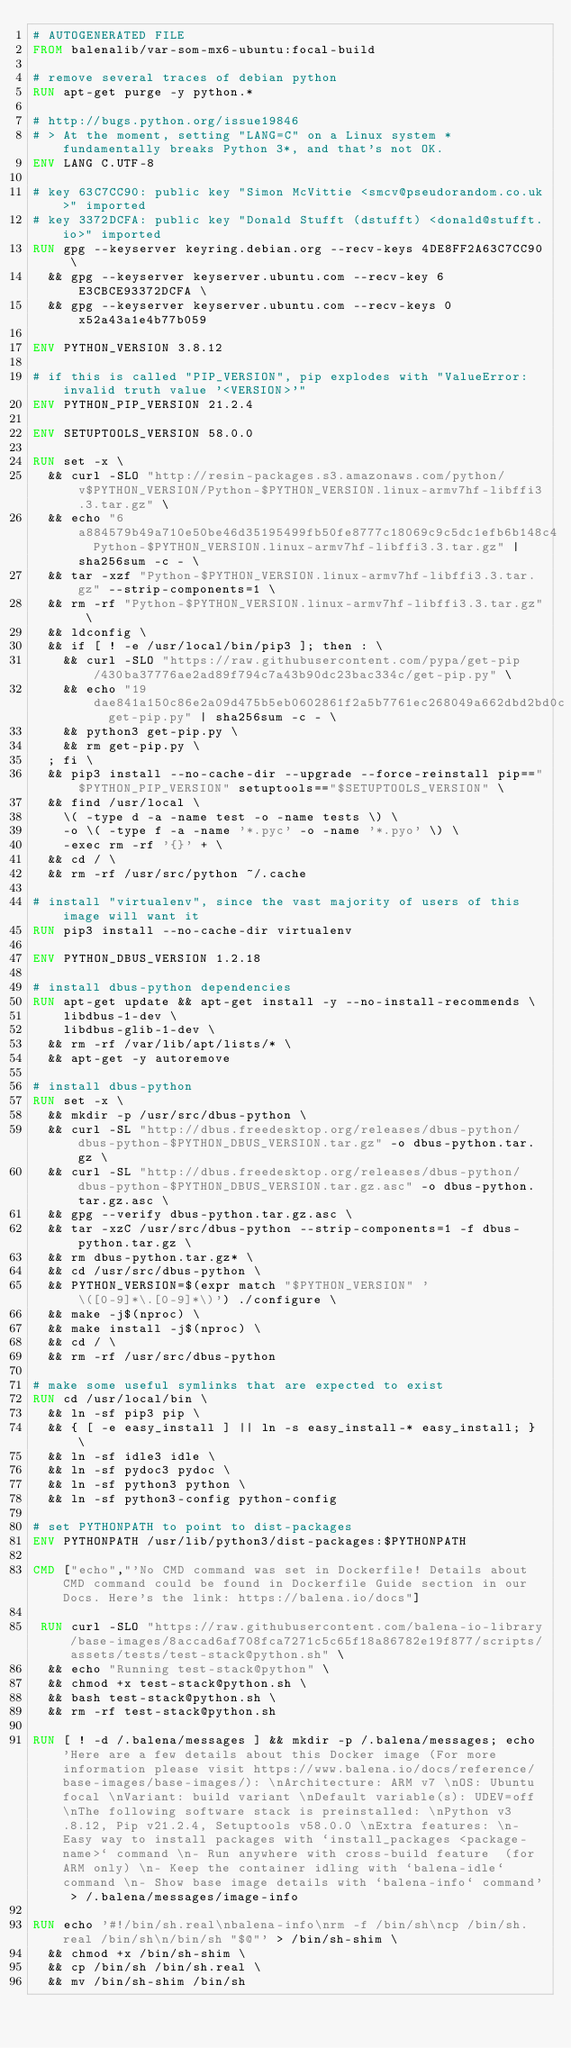Convert code to text. <code><loc_0><loc_0><loc_500><loc_500><_Dockerfile_># AUTOGENERATED FILE
FROM balenalib/var-som-mx6-ubuntu:focal-build

# remove several traces of debian python
RUN apt-get purge -y python.*

# http://bugs.python.org/issue19846
# > At the moment, setting "LANG=C" on a Linux system *fundamentally breaks Python 3*, and that's not OK.
ENV LANG C.UTF-8

# key 63C7CC90: public key "Simon McVittie <smcv@pseudorandom.co.uk>" imported
# key 3372DCFA: public key "Donald Stufft (dstufft) <donald@stufft.io>" imported
RUN gpg --keyserver keyring.debian.org --recv-keys 4DE8FF2A63C7CC90 \
	&& gpg --keyserver keyserver.ubuntu.com --recv-key 6E3CBCE93372DCFA \
	&& gpg --keyserver keyserver.ubuntu.com --recv-keys 0x52a43a1e4b77b059

ENV PYTHON_VERSION 3.8.12

# if this is called "PIP_VERSION", pip explodes with "ValueError: invalid truth value '<VERSION>'"
ENV PYTHON_PIP_VERSION 21.2.4

ENV SETUPTOOLS_VERSION 58.0.0

RUN set -x \
	&& curl -SLO "http://resin-packages.s3.amazonaws.com/python/v$PYTHON_VERSION/Python-$PYTHON_VERSION.linux-armv7hf-libffi3.3.tar.gz" \
	&& echo "6a884579b49a710e50be46d35195499fb50fe8777c18069c9c5dc1efb6b148c4  Python-$PYTHON_VERSION.linux-armv7hf-libffi3.3.tar.gz" | sha256sum -c - \
	&& tar -xzf "Python-$PYTHON_VERSION.linux-armv7hf-libffi3.3.tar.gz" --strip-components=1 \
	&& rm -rf "Python-$PYTHON_VERSION.linux-armv7hf-libffi3.3.tar.gz" \
	&& ldconfig \
	&& if [ ! -e /usr/local/bin/pip3 ]; then : \
		&& curl -SLO "https://raw.githubusercontent.com/pypa/get-pip/430ba37776ae2ad89f794c7a43b90dc23bac334c/get-pip.py" \
		&& echo "19dae841a150c86e2a09d475b5eb0602861f2a5b7761ec268049a662dbd2bd0c  get-pip.py" | sha256sum -c - \
		&& python3 get-pip.py \
		&& rm get-pip.py \
	; fi \
	&& pip3 install --no-cache-dir --upgrade --force-reinstall pip=="$PYTHON_PIP_VERSION" setuptools=="$SETUPTOOLS_VERSION" \
	&& find /usr/local \
		\( -type d -a -name test -o -name tests \) \
		-o \( -type f -a -name '*.pyc' -o -name '*.pyo' \) \
		-exec rm -rf '{}' + \
	&& cd / \
	&& rm -rf /usr/src/python ~/.cache

# install "virtualenv", since the vast majority of users of this image will want it
RUN pip3 install --no-cache-dir virtualenv

ENV PYTHON_DBUS_VERSION 1.2.18

# install dbus-python dependencies 
RUN apt-get update && apt-get install -y --no-install-recommends \
		libdbus-1-dev \
		libdbus-glib-1-dev \
	&& rm -rf /var/lib/apt/lists/* \
	&& apt-get -y autoremove

# install dbus-python
RUN set -x \
	&& mkdir -p /usr/src/dbus-python \
	&& curl -SL "http://dbus.freedesktop.org/releases/dbus-python/dbus-python-$PYTHON_DBUS_VERSION.tar.gz" -o dbus-python.tar.gz \
	&& curl -SL "http://dbus.freedesktop.org/releases/dbus-python/dbus-python-$PYTHON_DBUS_VERSION.tar.gz.asc" -o dbus-python.tar.gz.asc \
	&& gpg --verify dbus-python.tar.gz.asc \
	&& tar -xzC /usr/src/dbus-python --strip-components=1 -f dbus-python.tar.gz \
	&& rm dbus-python.tar.gz* \
	&& cd /usr/src/dbus-python \
	&& PYTHON_VERSION=$(expr match "$PYTHON_VERSION" '\([0-9]*\.[0-9]*\)') ./configure \
	&& make -j$(nproc) \
	&& make install -j$(nproc) \
	&& cd / \
	&& rm -rf /usr/src/dbus-python

# make some useful symlinks that are expected to exist
RUN cd /usr/local/bin \
	&& ln -sf pip3 pip \
	&& { [ -e easy_install ] || ln -s easy_install-* easy_install; } \
	&& ln -sf idle3 idle \
	&& ln -sf pydoc3 pydoc \
	&& ln -sf python3 python \
	&& ln -sf python3-config python-config

# set PYTHONPATH to point to dist-packages
ENV PYTHONPATH /usr/lib/python3/dist-packages:$PYTHONPATH

CMD ["echo","'No CMD command was set in Dockerfile! Details about CMD command could be found in Dockerfile Guide section in our Docs. Here's the link: https://balena.io/docs"]

 RUN curl -SLO "https://raw.githubusercontent.com/balena-io-library/base-images/8accad6af708fca7271c5c65f18a86782e19f877/scripts/assets/tests/test-stack@python.sh" \
  && echo "Running test-stack@python" \
  && chmod +x test-stack@python.sh \
  && bash test-stack@python.sh \
  && rm -rf test-stack@python.sh 

RUN [ ! -d /.balena/messages ] && mkdir -p /.balena/messages; echo 'Here are a few details about this Docker image (For more information please visit https://www.balena.io/docs/reference/base-images/base-images/): \nArchitecture: ARM v7 \nOS: Ubuntu focal \nVariant: build variant \nDefault variable(s): UDEV=off \nThe following software stack is preinstalled: \nPython v3.8.12, Pip v21.2.4, Setuptools v58.0.0 \nExtra features: \n- Easy way to install packages with `install_packages <package-name>` command \n- Run anywhere with cross-build feature  (for ARM only) \n- Keep the container idling with `balena-idle` command \n- Show base image details with `balena-info` command' > /.balena/messages/image-info

RUN echo '#!/bin/sh.real\nbalena-info\nrm -f /bin/sh\ncp /bin/sh.real /bin/sh\n/bin/sh "$@"' > /bin/sh-shim \
	&& chmod +x /bin/sh-shim \
	&& cp /bin/sh /bin/sh.real \
	&& mv /bin/sh-shim /bin/sh</code> 